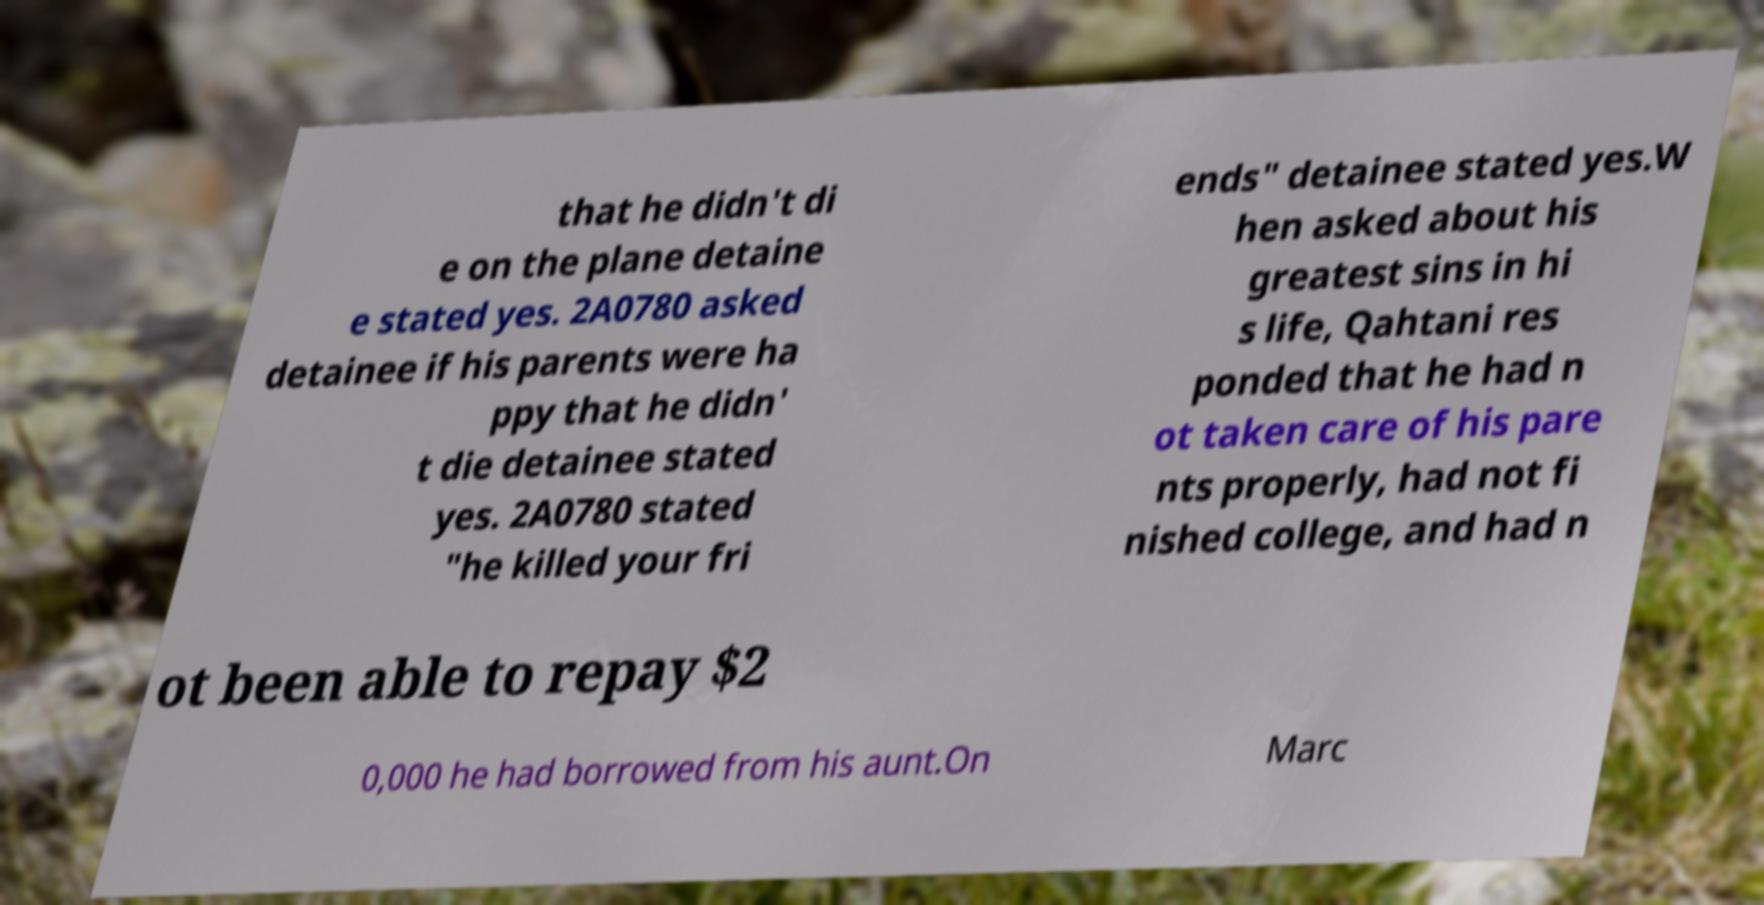Please identify and transcribe the text found in this image. that he didn't di e on the plane detaine e stated yes. 2A0780 asked detainee if his parents were ha ppy that he didn' t die detainee stated yes. 2A0780 stated "he killed your fri ends" detainee stated yes.W hen asked about his greatest sins in hi s life, Qahtani res ponded that he had n ot taken care of his pare nts properly, had not fi nished college, and had n ot been able to repay $2 0,000 he had borrowed from his aunt.On Marc 